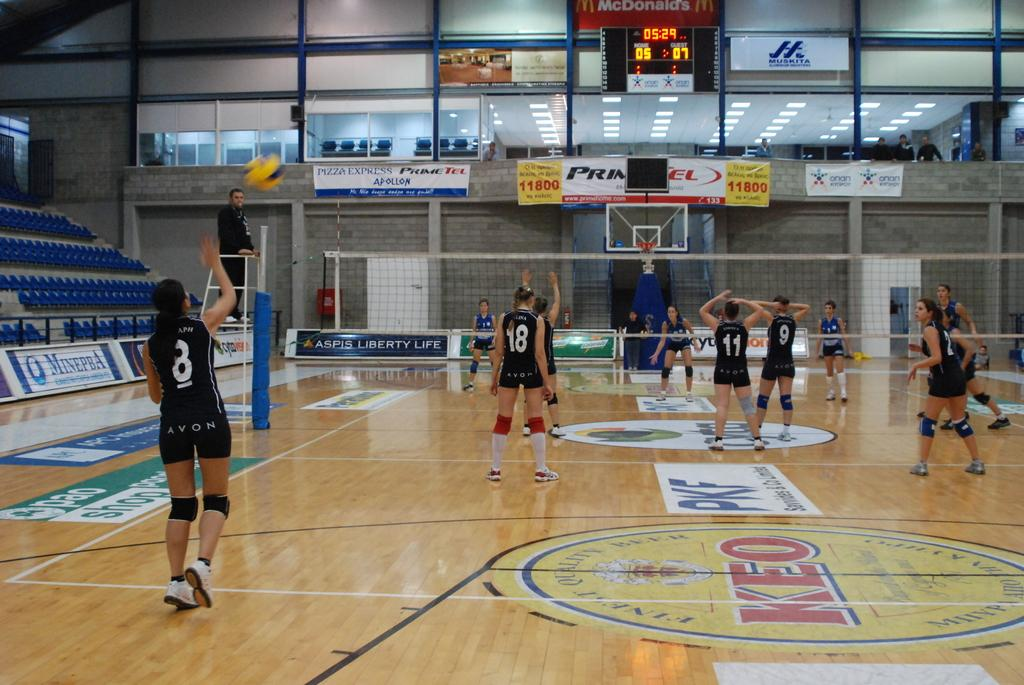<image>
Write a terse but informative summary of the picture. Avon basketball players 18, 11, and 9 face the hoop while player 8 takes her shot. 